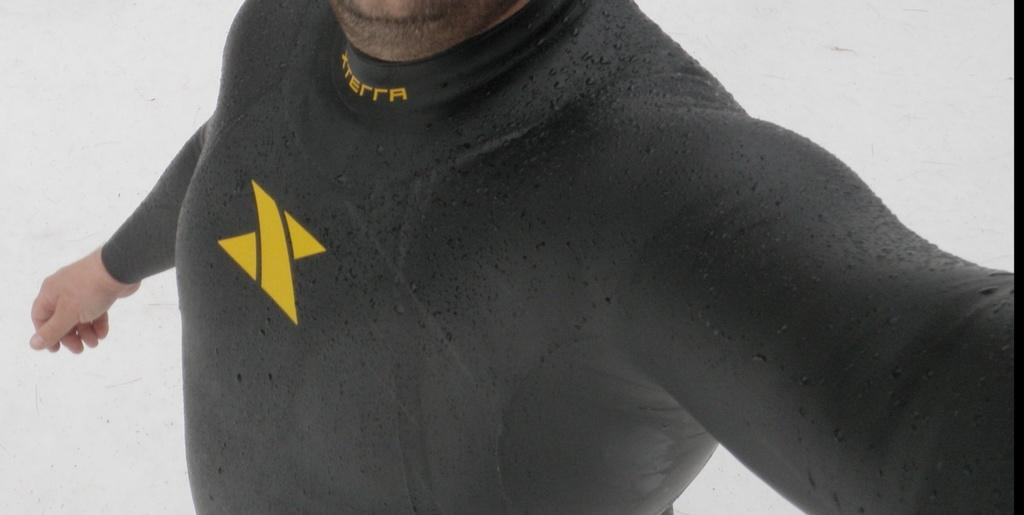What is the main subject of the image? There is a person in the image. What is the person wearing in the image? The person is wearing a black top. What color is the background of the image? The background of the image is white. What type of feather can be seen in the person's hand in the image? There is no feather present in the person's hand or anywhere else in the image. What decision is the person making in the image? The image does not provide any information about the person's decision-making process. How many potatoes are visible in the image? There are no potatoes present in the image. 